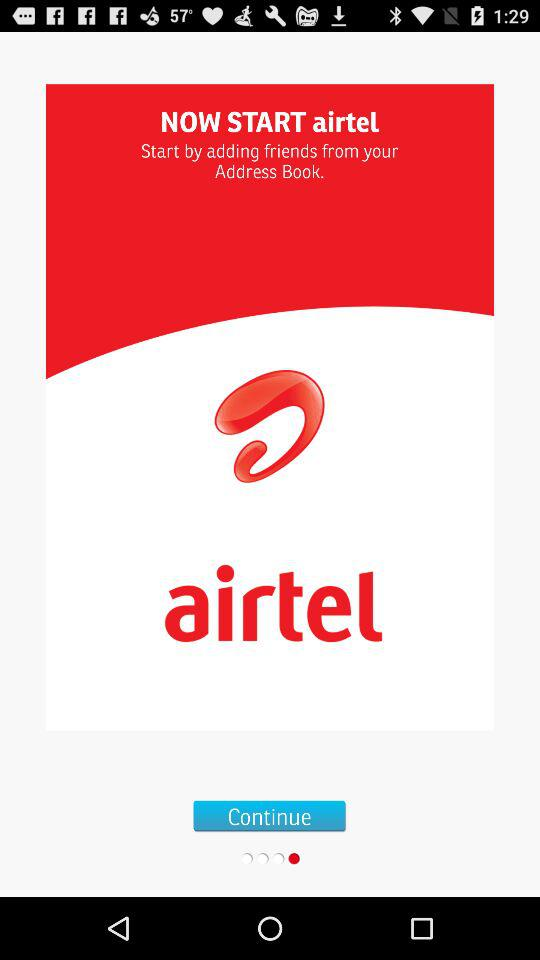What is the name of the application? The name of the application is "airtel". 